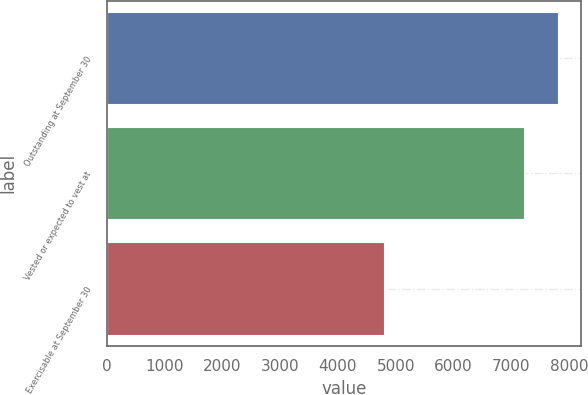Convert chart to OTSL. <chart><loc_0><loc_0><loc_500><loc_500><bar_chart><fcel>Outstanding at September 30<fcel>Vested or expected to vest at<fcel>Exercisable at September 30<nl><fcel>7811.8<fcel>7221<fcel>4794<nl></chart> 